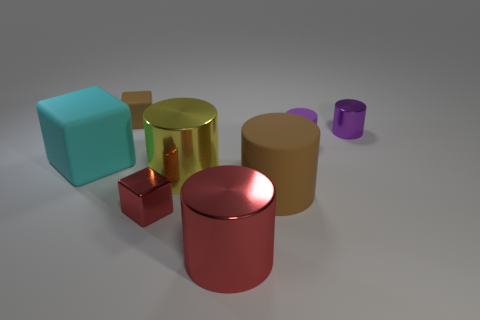Are there more tiny metal cylinders that are right of the metal cube than purple rubber objects?
Your answer should be very brief. No. What material is the object that is left of the brown rubber block on the left side of the tiny shiny object that is in front of the cyan rubber cube?
Give a very brief answer. Rubber. What number of objects are small rubber cylinders or small rubber things that are left of the tiny shiny cube?
Your response must be concise. 2. There is a large rubber object left of the small brown matte cube; does it have the same color as the tiny matte cylinder?
Keep it short and to the point. No. Are there more small purple rubber cylinders that are to the left of the brown matte cylinder than tiny red objects right of the purple metallic cylinder?
Ensure brevity in your answer.  No. Is there any other thing that is the same color as the tiny metal cylinder?
Keep it short and to the point. Yes. How many things are either gray shiny blocks or brown matte things?
Offer a terse response. 2. Is the size of the red shiny object on the right side of the yellow shiny cylinder the same as the small red block?
Your answer should be compact. No. How many other things are the same size as the yellow cylinder?
Make the answer very short. 3. Are any large matte cylinders visible?
Ensure brevity in your answer.  Yes. 